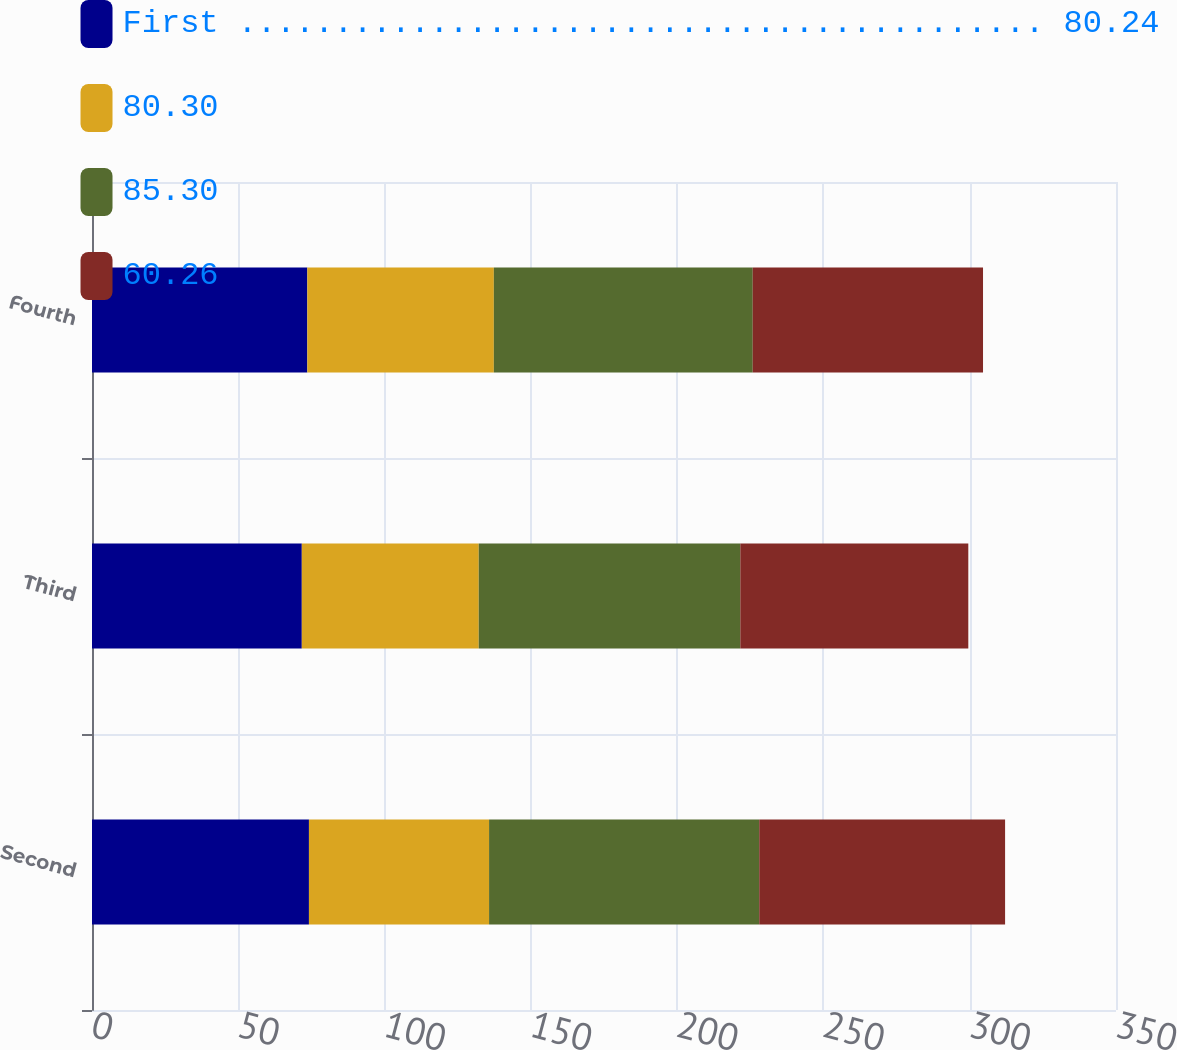Convert chart to OTSL. <chart><loc_0><loc_0><loc_500><loc_500><stacked_bar_chart><ecel><fcel>Second<fcel>Third<fcel>Fourth<nl><fcel>First .......................................... 80.24<fcel>74.15<fcel>71.71<fcel>73.6<nl><fcel>80.30<fcel>61.57<fcel>60.48<fcel>63.75<nl><fcel>85.30<fcel>92.34<fcel>89.4<fcel>88.49<nl><fcel>60.26<fcel>84.03<fcel>77.93<fcel>78.71<nl></chart> 